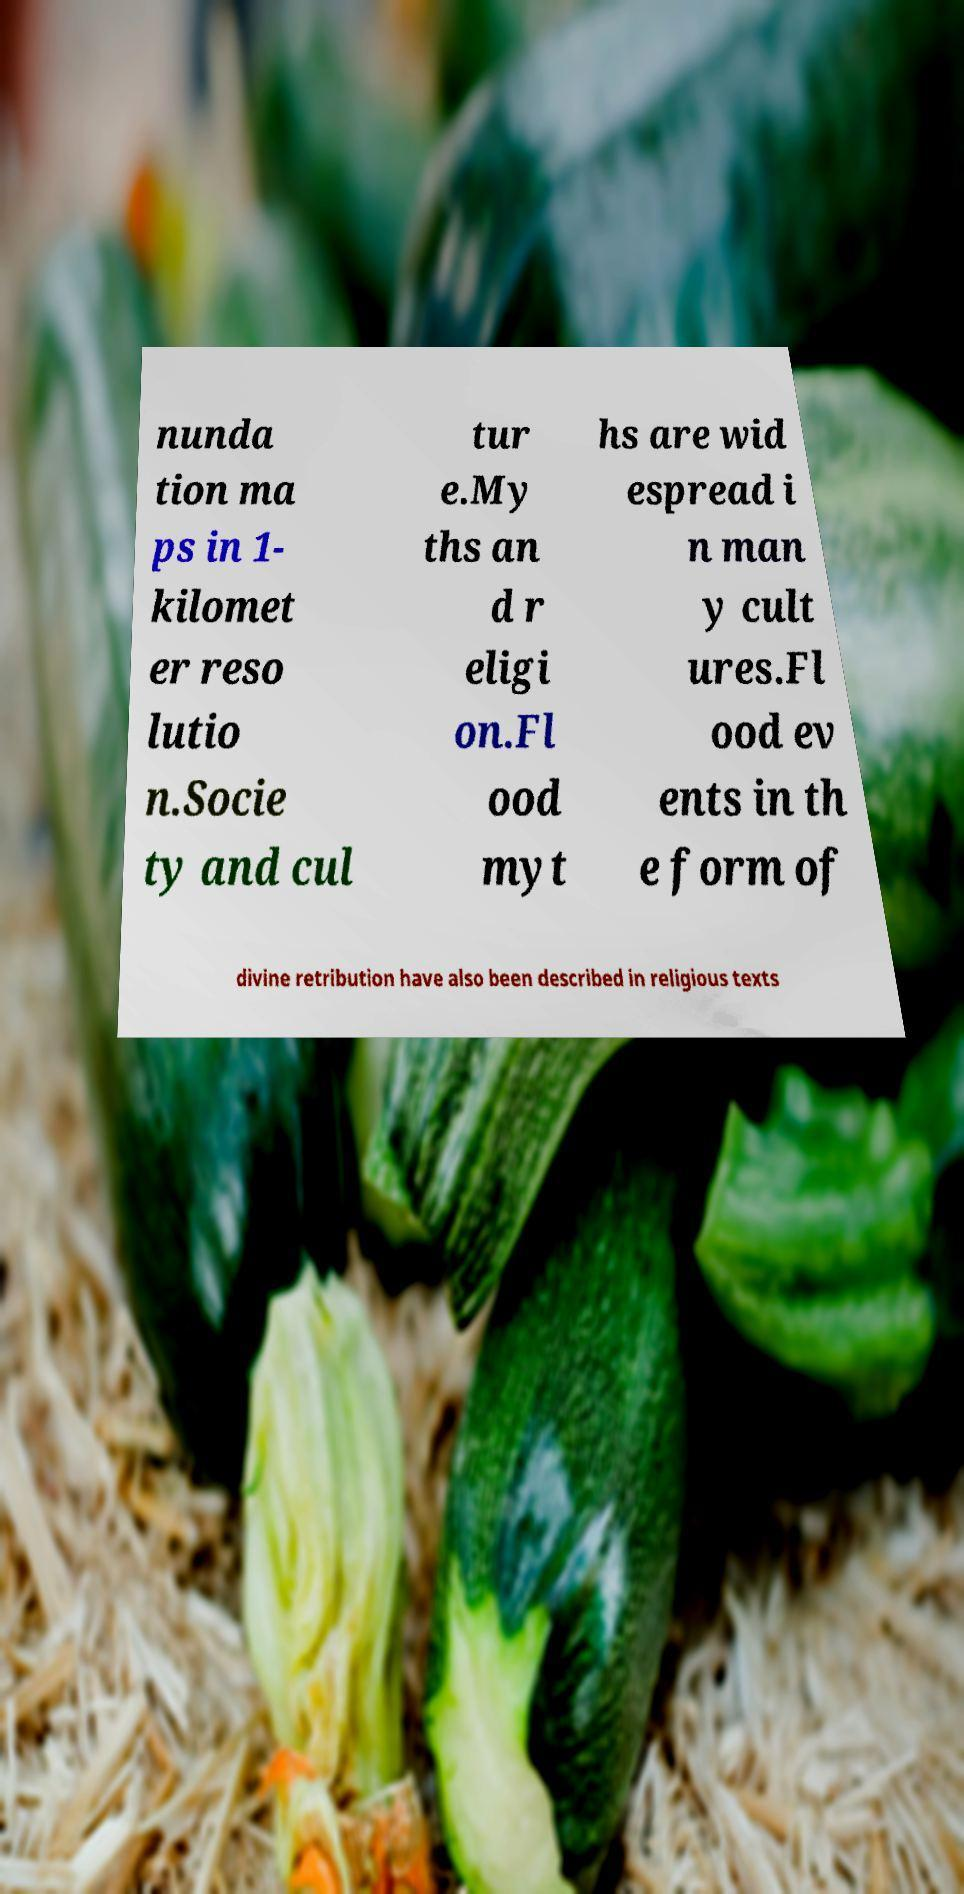For documentation purposes, I need the text within this image transcribed. Could you provide that? nunda tion ma ps in 1- kilomet er reso lutio n.Socie ty and cul tur e.My ths an d r eligi on.Fl ood myt hs are wid espread i n man y cult ures.Fl ood ev ents in th e form of divine retribution have also been described in religious texts 